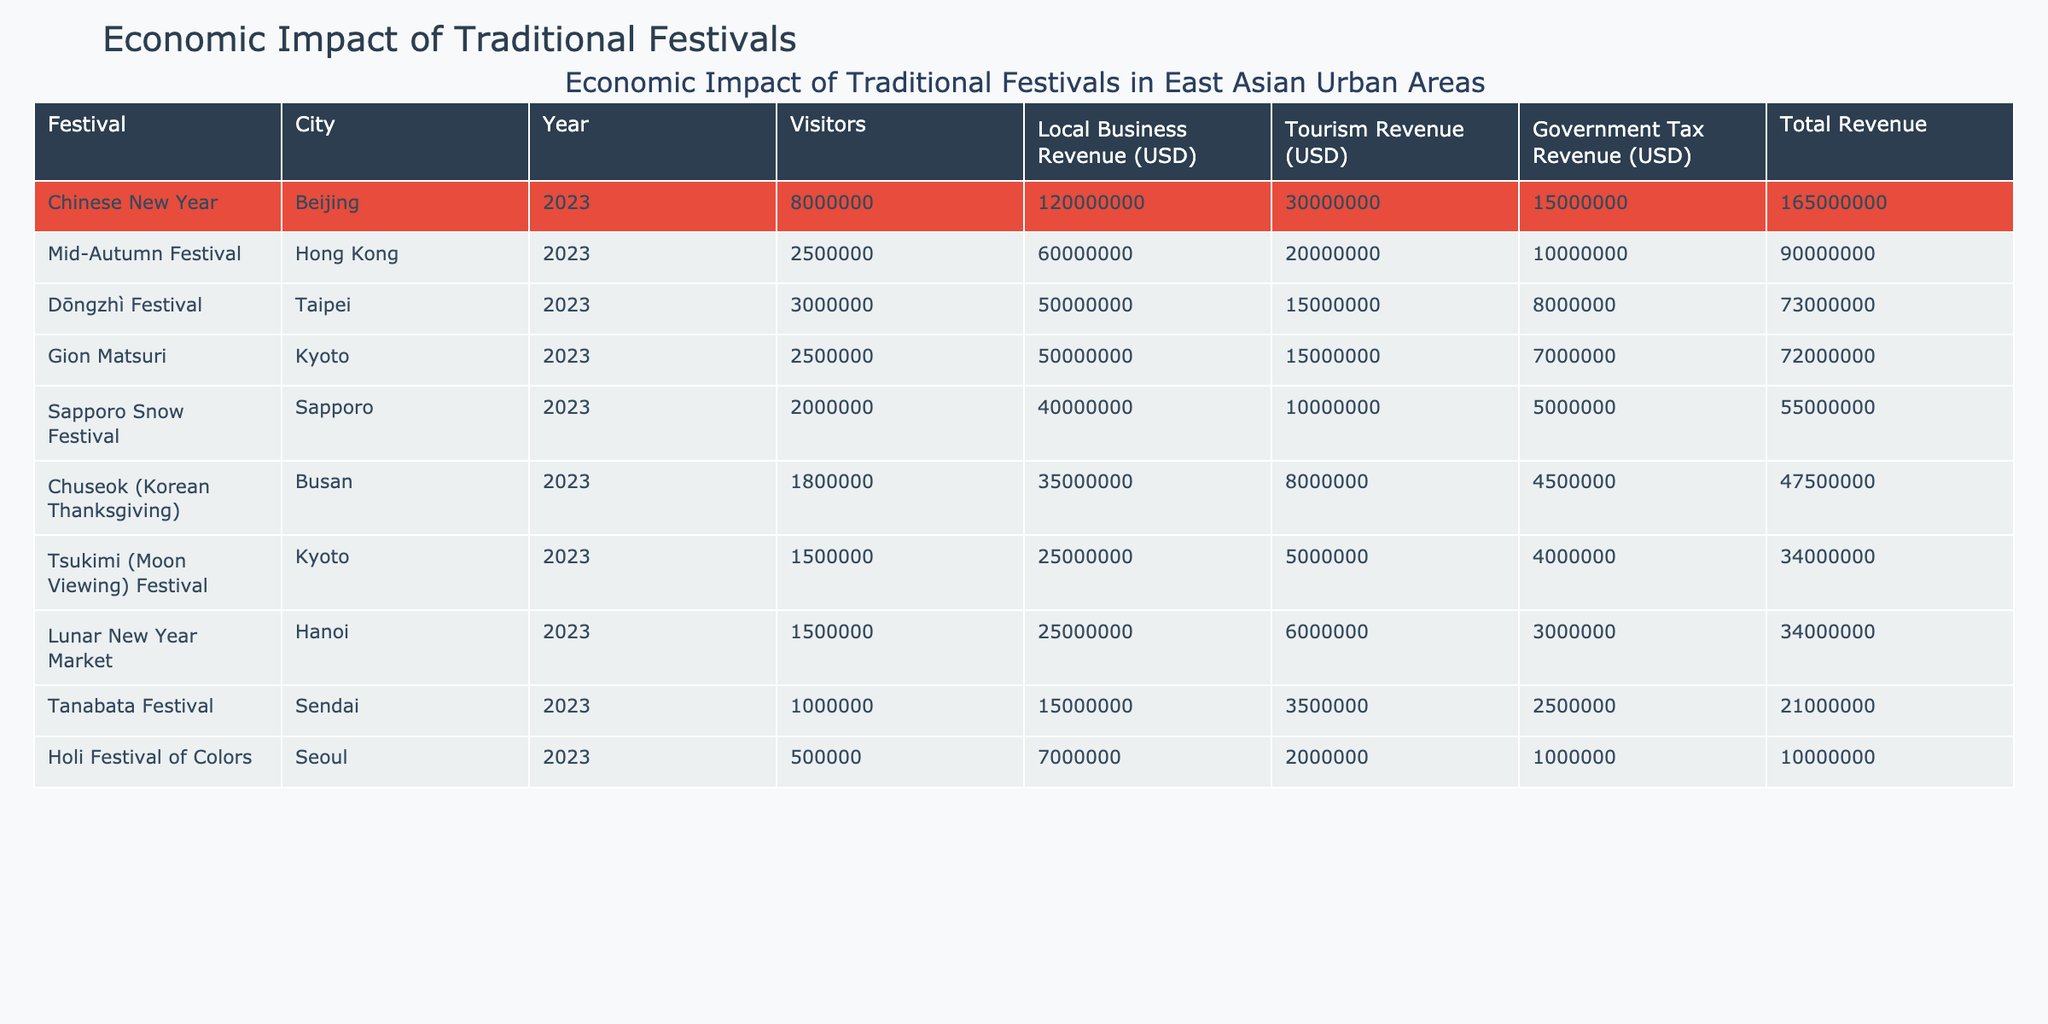What is the total revenue generated by the Chinese New Year festival in Beijing? The table shows that the Local Business Revenue is 120,000,000 USD, the Tourism Revenue is 30,000,000 USD, and the Government Tax Revenue is 15,000,000 USD. Adding these values together gives: 120,000,000 + 30,000,000 + 15,000,000 = 165,000,000 USD.
Answer: 165,000,000 USD Which city had the highest number of visitors during their festival? The table indicates that the Chinese New Year festival in Beijing had 8,000,000 visitors, which is greater than any other city listed.
Answer: Beijing How much did the Mid-Autumn Festival in Hong Kong contribute to the local business revenue? The table specifies that the Local Business Revenue for the Mid-Autumn Festival in Hong Kong is 60,000,000 USD.
Answer: 60,000,000 USD Is the government tax revenue from the Holi Festival of Colors in Seoul higher than that of the Chuseok festival in Busan? The table shows that the Government Tax Revenue for the Holi Festival is 1,000,000 USD, while for Chuseok it is 4,500,000 USD. Since 1,000,000 is less than 4,500,000, the statement is false.
Answer: No What is the difference in total revenue between the Dōngzhì Festival in Taipei and the Sapporo Snow Festival? For the Dōngzhì Festival, the total revenue is: 50,000,000 + 15,000,000 + 8,000,000 = 73,000,000 USD. For the Sapporo Snow Festival, it is: 40,000,000 + 10,000,000 + 5,000,000 = 55,000,000 USD. The difference in total revenue is: 73,000,000 - 55,000,000 = 18,000,000 USD.
Answer: 18,000,000 USD Which festival generated less than 10 million USD in government tax revenue? Looking at the table, the Holi Festival of Colors has a Government Tax Revenue of 1,000,000 USD, which is less than 10 million USD, whereas all other festivals have government tax revenues above this threshold.
Answer: Holi Festival of Colors Calculate the average number of visitors across all festivals listed in the table. Adding the visitors together: 8,000,000 + 3,000,000 + 1,500,000 + 2,000,000 + 500,000 + 1,800,000 + 1,000,000 + 2,500,000 + 1,500,000 = 21,300,000. There are 9 festivals, so the average is: 21,300,000 / 9 = 2,366,666.67, which rounds to 2,366,667.
Answer: 2,366,667 What percentage of total revenue does the government tax revenue represent for the Gion Matsuri Festival in Kyoto? The total revenue for Gion Matsuri is 50,000,000 (local) + 15,000,000 (tourism) + 7,000,000 (tax) = 72,000,000 USD. The government tax revenue is 7,000,000 USD. The percentage is calculated as: (7,000,000 / 72,000,000) * 100 = 9.72%.
Answer: 9.72% 